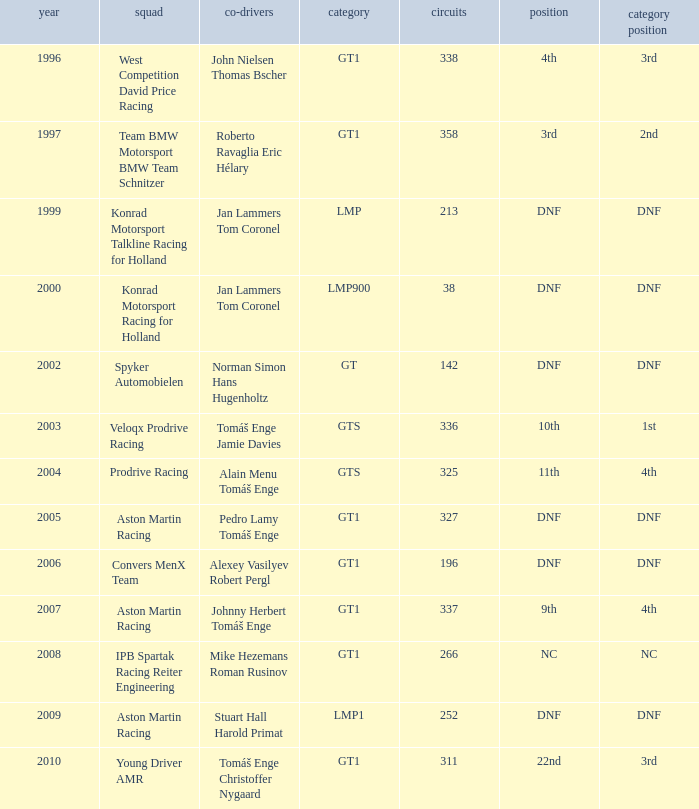What was the position in 1997? 3rd. 